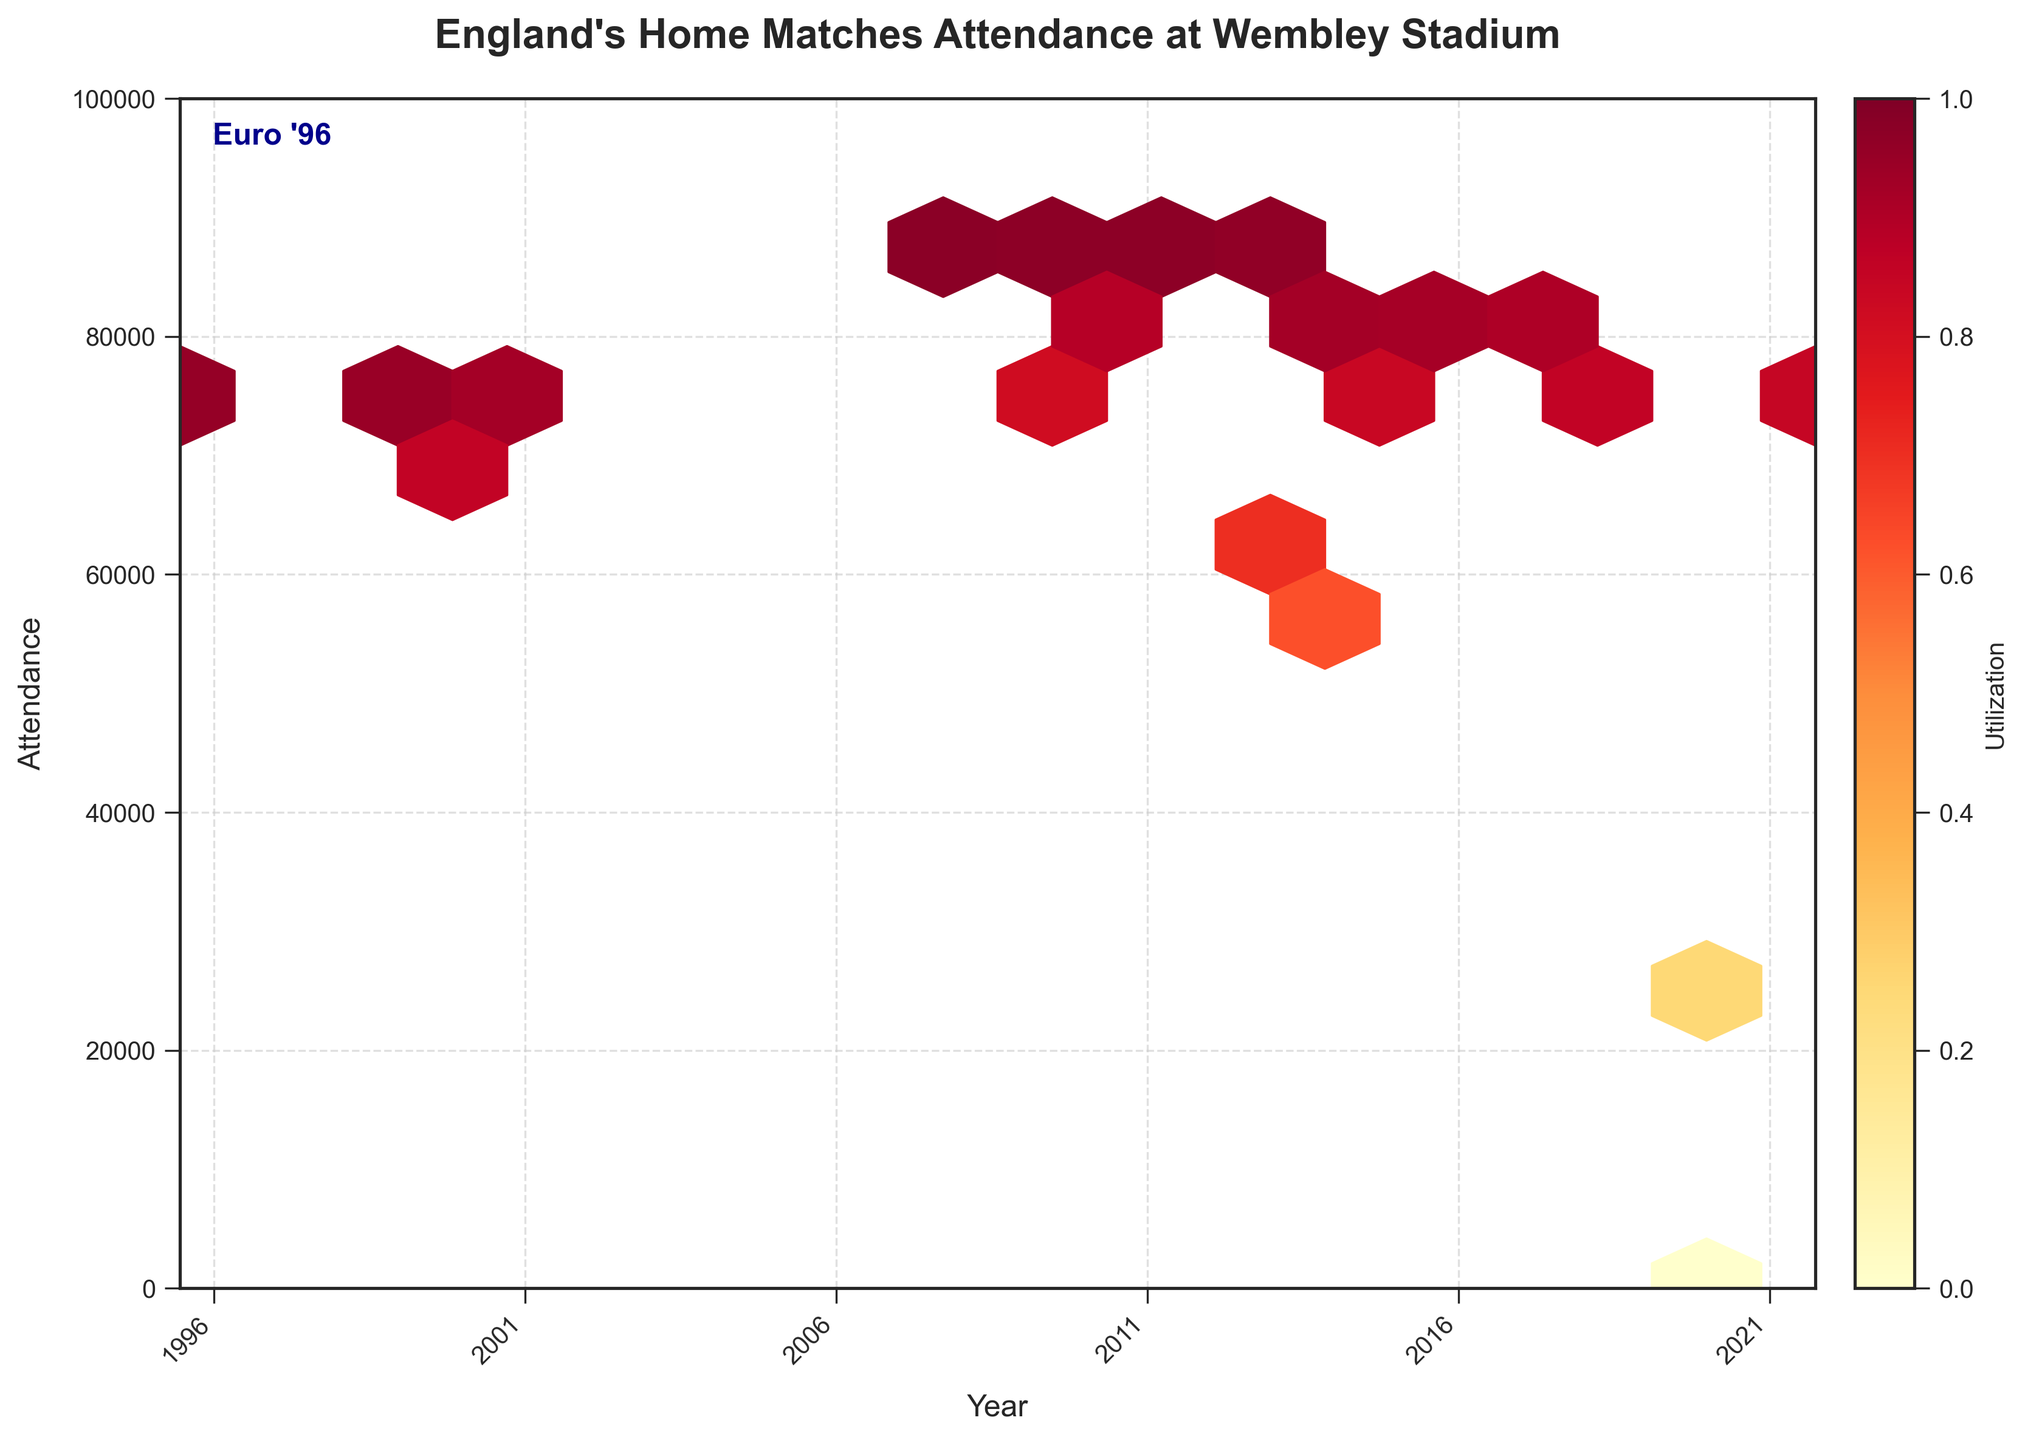What is the title of the figure? The title is usually placed prominently at the top of the figure. Look to see what is displayed there.
Answer: "England's Home Matches Attendance at Wembley Stadium" What does the color represent in the hexbin plot? In a hexbin plot, the color usually represents an additional variable. The figure legend indicates that color represents 'Utilization'.
Answer: Utilization How many matches had attendance figures above 80,000? To determine this, locate hexbin cells that are positioned above the 80,000 line on the y-axis. Then count these cells.
Answer: 11 Which year had the highest peak in match attendance? This can be identified by finding the tallest peak in attendance in the hexbin plot and noting the corresponding year on the x-axis.
Answer: 2008 How does the utilization rate change over the years? Check the color gradation of the hexbin cells from left to right in the plot. Brighter colors towards the right signify higher utilization rates.
Answer: Utilization generally increases over the years, peaking around 2008-2011 Why do some matches show zero attendance? Zero attendance is indicated by hexbin cells at the bottom of the y-axis. These cells usually indicate matches affected by special circumstances, like the COVID-19 pandemic.
Answer: Due to COVID-19 Which matches approximately have the highest utilization rate? The cells with the darkest colors around the top of the y-axis indicate highest utilization. These correspond to matches in 2008 and around 2013.
Answer: Matches in 2008 and 2013 Compare the utilization rates in Euro '96 matches vs later years. Identify the hexbin cells around 1996 and compare their colors to later years. The earlier cells are moderately colored while some of the later cells are brighter, indicating higher utilization rates in recent years.
Answer: Utilization rates are generally higher in later years What's the trend in attendance figures for England's home matches from Euro '96 to 2022? Observe the general pattern in the distribution of hexbin cells along the x-axis. The trend line should be considered as it moves from left to right.
Answer: The attendance figures show a general upward trend from Euro '96 to around 2008, with some fluctuations thereafter 